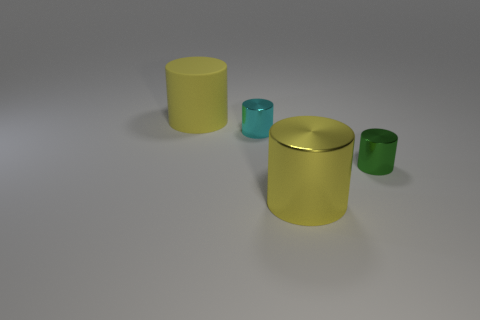Add 1 small green metal cylinders. How many objects exist? 5 Add 4 cyan cylinders. How many cyan cylinders are left? 5 Add 4 big cyan shiny spheres. How many big cyan shiny spheres exist? 4 Subtract 0 gray blocks. How many objects are left? 4 Subtract all tiny green cylinders. Subtract all small red shiny spheres. How many objects are left? 3 